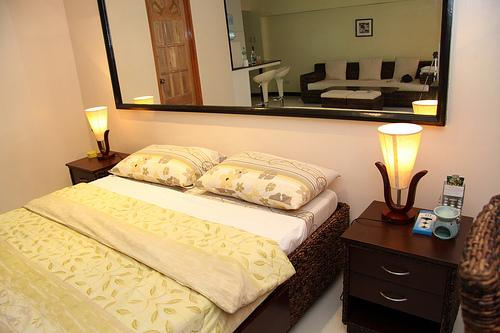Mention the colors and textures of major objects in the image. The bed has a cream comforter, the nightstand has a brown wood texture, the lamp has a warm glow, and the mirror has a rich wooden frame. Give a concise description of the main elements in the image without mentioning specific details. A well-furnished bedroom featuring a bed, a nightstand with a lamp, and a large mirror with a wooden frame. Describe the contents and style of the image as if you were explaining it to someone who cannot see it. Imagine a cozy, inviting bedroom with a luxurious bed adorned with decorative pillows and a cream comforter, a wooden nightstand that has a glowing lamp enhancing the ambience, and a grand mirror on the wall reflecting the room's serene atmosphere. Provide a brief description of the main elements present in the image. A bed with pillows, nightstand with a lamp, a mirror reflecting a couch, and a picture on the wall are the main elements in the image. What type of furniture are present in the image and how are they arranged? There is a bed, a nightstand, and chairs; the bed is in the lower part of the image with the nightstand next to it, chairs are nearby, and a mirror is above the bed. List three main objects in the image along with one specific detail about each object. 3. Mirror - having a wooden frame and reflecting the room. Describe the image using adjectives and details that make it seem luxurious. A lavish queen-size bed with intricate pillows, an elegant wooden nightstand adorned with a glowing lamp, and a grand mirror with a majestic wooden frame dominate the image. Identify the main piece of furniture in the image and its characteristics. The main piece of furniture is a bed with two pillows, a white sheet, and a turned down top of the bedspread, matching a lavish cream comforter. Use a single sentence to describe the image with as much detail as possible. A tastefully designed bedroom showcases a plush bed with numerous pillows and a tufted comforter, a wooden nightstand supporting a warmly lit lamp, and an ornate mirror reflecting the room. Enumerate three main objects and their locations in the image. A bed with two pillows, located on the bottom left; a wooden nightstand with a lamp, located on the right side; and a large mirror, located at the top. 